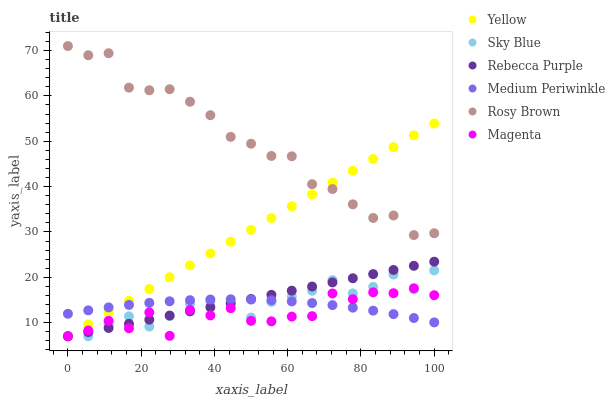Does Magenta have the minimum area under the curve?
Answer yes or no. Yes. Does Rosy Brown have the maximum area under the curve?
Answer yes or no. Yes. Does Medium Periwinkle have the minimum area under the curve?
Answer yes or no. No. Does Medium Periwinkle have the maximum area under the curve?
Answer yes or no. No. Is Rebecca Purple the smoothest?
Answer yes or no. Yes. Is Magenta the roughest?
Answer yes or no. Yes. Is Medium Periwinkle the smoothest?
Answer yes or no. No. Is Medium Periwinkle the roughest?
Answer yes or no. No. Does Yellow have the lowest value?
Answer yes or no. Yes. Does Medium Periwinkle have the lowest value?
Answer yes or no. No. Does Rosy Brown have the highest value?
Answer yes or no. Yes. Does Yellow have the highest value?
Answer yes or no. No. Is Sky Blue less than Rosy Brown?
Answer yes or no. Yes. Is Rosy Brown greater than Magenta?
Answer yes or no. Yes. Does Yellow intersect Magenta?
Answer yes or no. Yes. Is Yellow less than Magenta?
Answer yes or no. No. Is Yellow greater than Magenta?
Answer yes or no. No. Does Sky Blue intersect Rosy Brown?
Answer yes or no. No. 